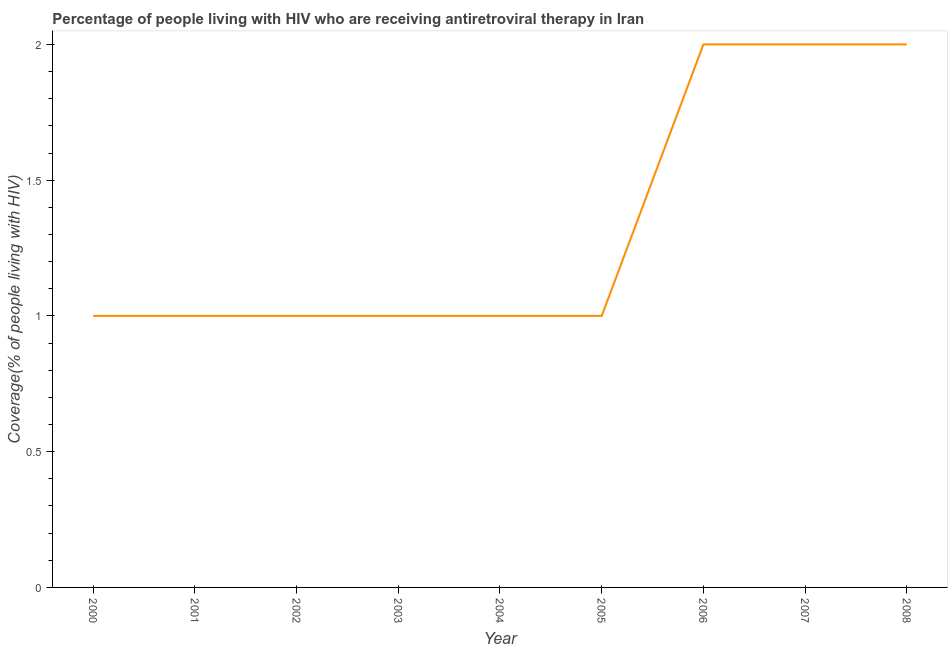What is the antiretroviral therapy coverage in 2005?
Keep it short and to the point. 1. Across all years, what is the maximum antiretroviral therapy coverage?
Your response must be concise. 2. Across all years, what is the minimum antiretroviral therapy coverage?
Provide a short and direct response. 1. In which year was the antiretroviral therapy coverage minimum?
Your answer should be very brief. 2000. What is the sum of the antiretroviral therapy coverage?
Provide a succinct answer. 12. What is the difference between the antiretroviral therapy coverage in 2003 and 2007?
Provide a short and direct response. -1. What is the average antiretroviral therapy coverage per year?
Your answer should be compact. 1.33. What is the median antiretroviral therapy coverage?
Offer a terse response. 1. In how many years, is the antiretroviral therapy coverage greater than 0.2 %?
Make the answer very short. 9. Is the antiretroviral therapy coverage in 2000 less than that in 2002?
Your response must be concise. No. What is the difference between the highest and the second highest antiretroviral therapy coverage?
Provide a succinct answer. 0. Is the sum of the antiretroviral therapy coverage in 2006 and 2007 greater than the maximum antiretroviral therapy coverage across all years?
Your answer should be compact. Yes. What is the difference between the highest and the lowest antiretroviral therapy coverage?
Give a very brief answer. 1. In how many years, is the antiretroviral therapy coverage greater than the average antiretroviral therapy coverage taken over all years?
Keep it short and to the point. 3. Does the antiretroviral therapy coverage monotonically increase over the years?
Provide a short and direct response. No. How many lines are there?
Make the answer very short. 1. How many years are there in the graph?
Ensure brevity in your answer.  9. What is the difference between two consecutive major ticks on the Y-axis?
Ensure brevity in your answer.  0.5. Does the graph contain any zero values?
Your response must be concise. No. Does the graph contain grids?
Your answer should be compact. No. What is the title of the graph?
Give a very brief answer. Percentage of people living with HIV who are receiving antiretroviral therapy in Iran. What is the label or title of the Y-axis?
Offer a very short reply. Coverage(% of people living with HIV). What is the Coverage(% of people living with HIV) in 2004?
Offer a terse response. 1. What is the Coverage(% of people living with HIV) of 2006?
Your response must be concise. 2. What is the Coverage(% of people living with HIV) in 2007?
Ensure brevity in your answer.  2. What is the difference between the Coverage(% of people living with HIV) in 2000 and 2002?
Your response must be concise. 0. What is the difference between the Coverage(% of people living with HIV) in 2000 and 2003?
Give a very brief answer. 0. What is the difference between the Coverage(% of people living with HIV) in 2000 and 2005?
Make the answer very short. 0. What is the difference between the Coverage(% of people living with HIV) in 2000 and 2007?
Your response must be concise. -1. What is the difference between the Coverage(% of people living with HIV) in 2000 and 2008?
Make the answer very short. -1. What is the difference between the Coverage(% of people living with HIV) in 2001 and 2002?
Provide a succinct answer. 0. What is the difference between the Coverage(% of people living with HIV) in 2001 and 2003?
Give a very brief answer. 0. What is the difference between the Coverage(% of people living with HIV) in 2001 and 2006?
Keep it short and to the point. -1. What is the difference between the Coverage(% of people living with HIV) in 2001 and 2008?
Provide a short and direct response. -1. What is the difference between the Coverage(% of people living with HIV) in 2002 and 2004?
Your response must be concise. 0. What is the difference between the Coverage(% of people living with HIV) in 2002 and 2007?
Offer a very short reply. -1. What is the difference between the Coverage(% of people living with HIV) in 2003 and 2006?
Provide a succinct answer. -1. What is the difference between the Coverage(% of people living with HIV) in 2003 and 2007?
Provide a succinct answer. -1. What is the difference between the Coverage(% of people living with HIV) in 2004 and 2006?
Offer a very short reply. -1. What is the difference between the Coverage(% of people living with HIV) in 2004 and 2007?
Offer a terse response. -1. What is the difference between the Coverage(% of people living with HIV) in 2005 and 2006?
Your answer should be very brief. -1. What is the difference between the Coverage(% of people living with HIV) in 2005 and 2008?
Make the answer very short. -1. What is the difference between the Coverage(% of people living with HIV) in 2006 and 2007?
Ensure brevity in your answer.  0. What is the difference between the Coverage(% of people living with HIV) in 2007 and 2008?
Your response must be concise. 0. What is the ratio of the Coverage(% of people living with HIV) in 2000 to that in 2001?
Your response must be concise. 1. What is the ratio of the Coverage(% of people living with HIV) in 2000 to that in 2003?
Give a very brief answer. 1. What is the ratio of the Coverage(% of people living with HIV) in 2000 to that in 2007?
Ensure brevity in your answer.  0.5. What is the ratio of the Coverage(% of people living with HIV) in 2001 to that in 2003?
Provide a short and direct response. 1. What is the ratio of the Coverage(% of people living with HIV) in 2001 to that in 2004?
Your answer should be compact. 1. What is the ratio of the Coverage(% of people living with HIV) in 2001 to that in 2006?
Ensure brevity in your answer.  0.5. What is the ratio of the Coverage(% of people living with HIV) in 2001 to that in 2008?
Provide a short and direct response. 0.5. What is the ratio of the Coverage(% of people living with HIV) in 2002 to that in 2004?
Ensure brevity in your answer.  1. What is the ratio of the Coverage(% of people living with HIV) in 2002 to that in 2007?
Your answer should be very brief. 0.5. What is the ratio of the Coverage(% of people living with HIV) in 2003 to that in 2005?
Give a very brief answer. 1. What is the ratio of the Coverage(% of people living with HIV) in 2004 to that in 2006?
Provide a succinct answer. 0.5. What is the ratio of the Coverage(% of people living with HIV) in 2004 to that in 2007?
Provide a succinct answer. 0.5. What is the ratio of the Coverage(% of people living with HIV) in 2004 to that in 2008?
Offer a terse response. 0.5. What is the ratio of the Coverage(% of people living with HIV) in 2005 to that in 2006?
Your answer should be compact. 0.5. What is the ratio of the Coverage(% of people living with HIV) in 2005 to that in 2007?
Make the answer very short. 0.5. What is the ratio of the Coverage(% of people living with HIV) in 2006 to that in 2007?
Ensure brevity in your answer.  1. What is the ratio of the Coverage(% of people living with HIV) in 2007 to that in 2008?
Keep it short and to the point. 1. 